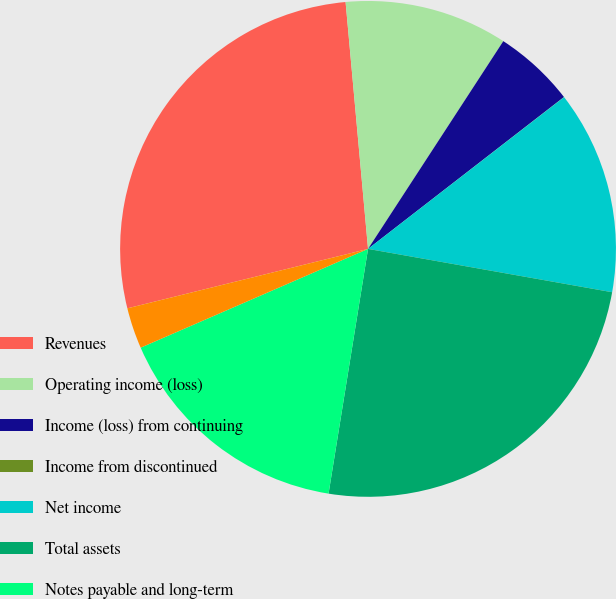<chart> <loc_0><loc_0><loc_500><loc_500><pie_chart><fcel>Revenues<fcel>Operating income (loss)<fcel>Income (loss) from continuing<fcel>Income from discontinued<fcel>Net income<fcel>Total assets<fcel>Notes payable and long-term<fcel>Other long-term liabilities<nl><fcel>27.41%<fcel>10.63%<fcel>5.32%<fcel>0.01%<fcel>13.28%<fcel>24.75%<fcel>15.93%<fcel>2.67%<nl></chart> 